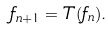Convert formula to latex. <formula><loc_0><loc_0><loc_500><loc_500>f _ { n + 1 } = T ( f _ { n } ) .</formula> 